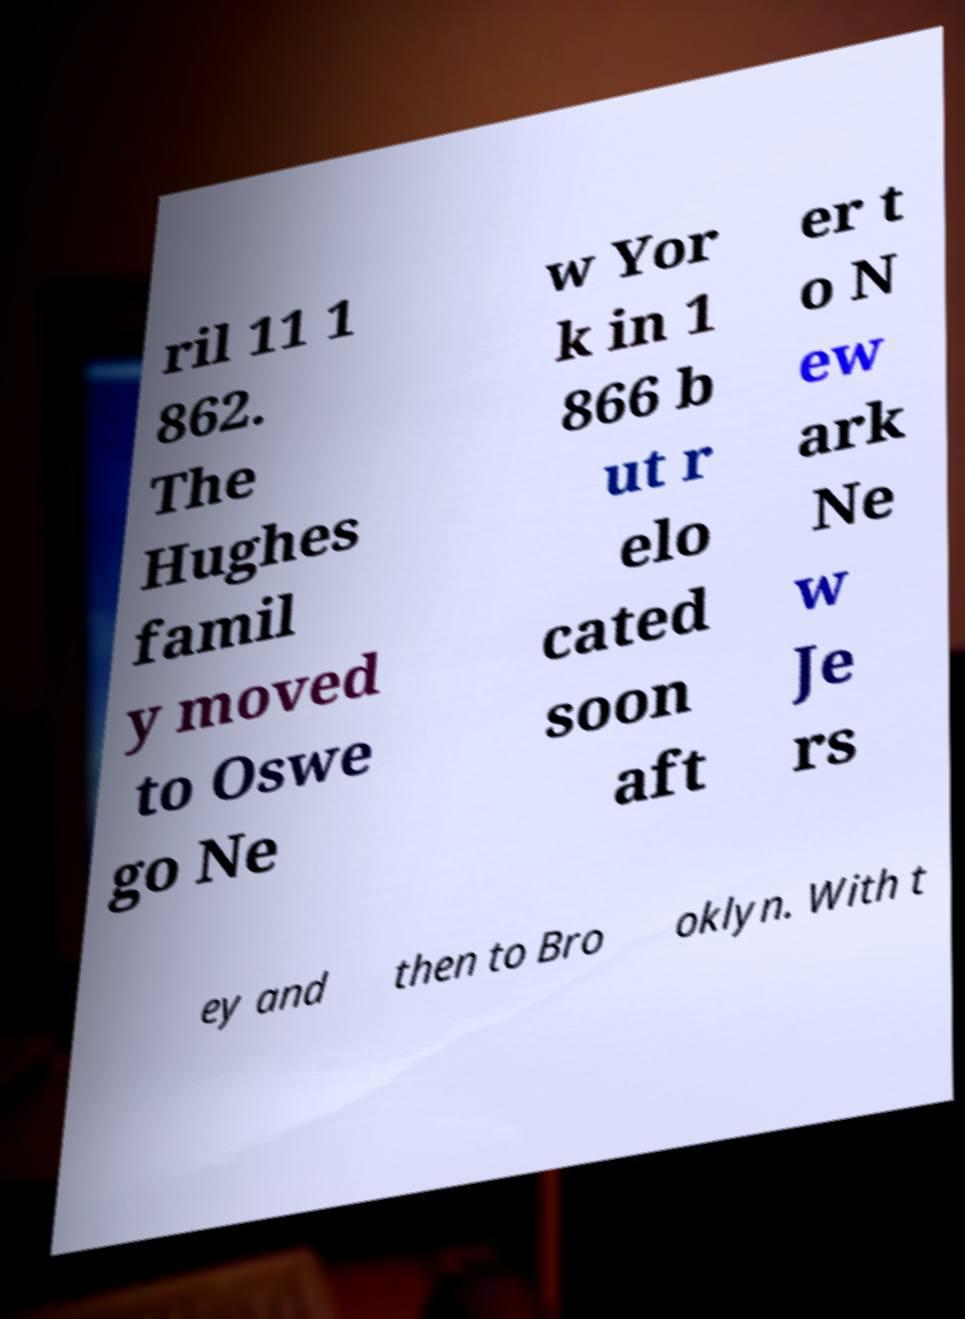Can you accurately transcribe the text from the provided image for me? ril 11 1 862. The Hughes famil y moved to Oswe go Ne w Yor k in 1 866 b ut r elo cated soon aft er t o N ew ark Ne w Je rs ey and then to Bro oklyn. With t 